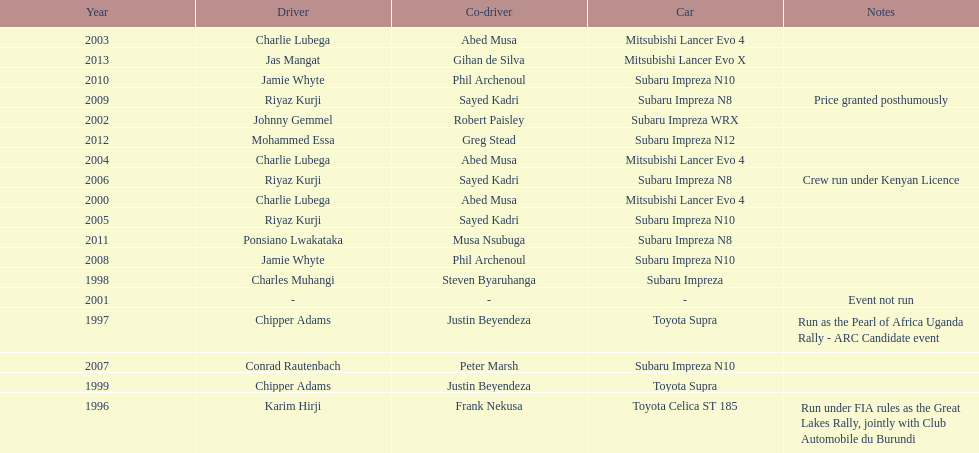Parse the table in full. {'header': ['Year', 'Driver', 'Co-driver', 'Car', 'Notes'], 'rows': [['2003', 'Charlie Lubega', 'Abed Musa', 'Mitsubishi Lancer Evo 4', ''], ['2013', 'Jas Mangat', 'Gihan de Silva', 'Mitsubishi Lancer Evo X', ''], ['2010', 'Jamie Whyte', 'Phil Archenoul', 'Subaru Impreza N10', ''], ['2009', 'Riyaz Kurji', 'Sayed Kadri', 'Subaru Impreza N8', 'Price granted posthumously'], ['2002', 'Johnny Gemmel', 'Robert Paisley', 'Subaru Impreza WRX', ''], ['2012', 'Mohammed Essa', 'Greg Stead', 'Subaru Impreza N12', ''], ['2004', 'Charlie Lubega', 'Abed Musa', 'Mitsubishi Lancer Evo 4', ''], ['2006', 'Riyaz Kurji', 'Sayed Kadri', 'Subaru Impreza N8', 'Crew run under Kenyan Licence'], ['2000', 'Charlie Lubega', 'Abed Musa', 'Mitsubishi Lancer Evo 4', ''], ['2005', 'Riyaz Kurji', 'Sayed Kadri', 'Subaru Impreza N10', ''], ['2011', 'Ponsiano Lwakataka', 'Musa Nsubuga', 'Subaru Impreza N8', ''], ['2008', 'Jamie Whyte', 'Phil Archenoul', 'Subaru Impreza N10', ''], ['1998', 'Charles Muhangi', 'Steven Byaruhanga', 'Subaru Impreza', ''], ['2001', '-', '-', '-', 'Event not run'], ['1997', 'Chipper Adams', 'Justin Beyendeza', 'Toyota Supra', 'Run as the Pearl of Africa Uganda Rally - ARC Candidate event'], ['2007', 'Conrad Rautenbach', 'Peter Marsh', 'Subaru Impreza N10', ''], ['1999', 'Chipper Adams', 'Justin Beyendeza', 'Toyota Supra', ''], ['1996', 'Karim Hirji', 'Frank Nekusa', 'Toyota Celica ST 185', 'Run under FIA rules as the Great Lakes Rally, jointly with Club Automobile du Burundi']]} How many times was a mitsubishi lancer the winning car before the year 2004? 2. 